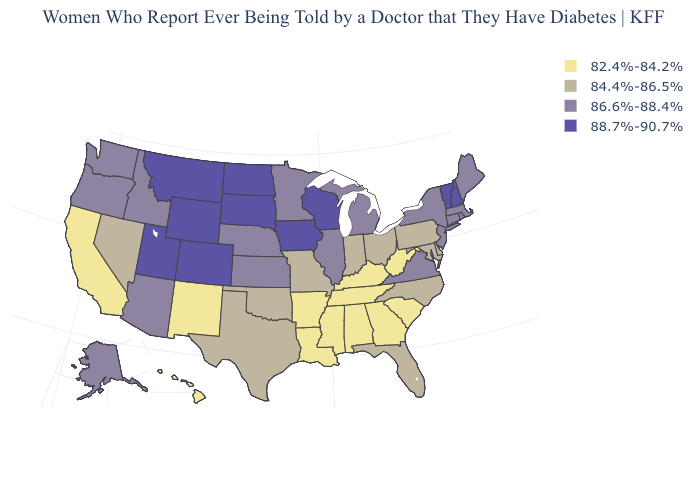What is the value of West Virginia?
Write a very short answer. 82.4%-84.2%. What is the value of Georgia?
Quick response, please. 82.4%-84.2%. What is the value of Louisiana?
Be succinct. 82.4%-84.2%. What is the value of Indiana?
Short answer required. 84.4%-86.5%. Name the states that have a value in the range 86.6%-88.4%?
Give a very brief answer. Alaska, Arizona, Connecticut, Idaho, Illinois, Kansas, Maine, Massachusetts, Michigan, Minnesota, Nebraska, New Jersey, New York, Oregon, Rhode Island, Virginia, Washington. What is the value of Georgia?
Short answer required. 82.4%-84.2%. Does Minnesota have the lowest value in the MidWest?
Quick response, please. No. Which states have the lowest value in the South?
Short answer required. Alabama, Arkansas, Georgia, Kentucky, Louisiana, Mississippi, South Carolina, Tennessee, West Virginia. Name the states that have a value in the range 84.4%-86.5%?
Give a very brief answer. Delaware, Florida, Indiana, Maryland, Missouri, Nevada, North Carolina, Ohio, Oklahoma, Pennsylvania, Texas. Does the map have missing data?
Answer briefly. No. What is the highest value in states that border Illinois?
Write a very short answer. 88.7%-90.7%. Name the states that have a value in the range 86.6%-88.4%?
Write a very short answer. Alaska, Arizona, Connecticut, Idaho, Illinois, Kansas, Maine, Massachusetts, Michigan, Minnesota, Nebraska, New Jersey, New York, Oregon, Rhode Island, Virginia, Washington. How many symbols are there in the legend?
Keep it brief. 4. What is the value of Tennessee?
Answer briefly. 82.4%-84.2%. Is the legend a continuous bar?
Be succinct. No. 